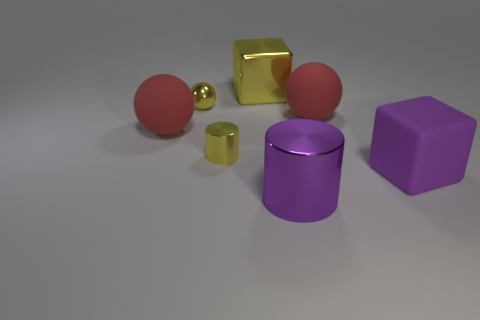The big object that is the same color as the small cylinder is what shape?
Make the answer very short. Cube. Does the small ball have the same color as the large metal block?
Offer a terse response. Yes. There is a shiny cylinder to the left of the purple cylinder; does it have the same size as the big cylinder?
Your response must be concise. No. How many other objects are the same shape as the purple matte thing?
Make the answer very short. 1. What number of brown objects are small spheres or small matte objects?
Ensure brevity in your answer.  0. There is a big cube that is to the right of the large purple metal object; does it have the same color as the big cylinder?
Ensure brevity in your answer.  Yes. The large thing that is the same material as the yellow cube is what shape?
Keep it short and to the point. Cylinder. There is a object that is right of the large shiny cylinder and behind the big purple matte object; what color is it?
Your answer should be compact. Red. There is a rubber ball that is in front of the red matte sphere to the right of the tiny cylinder; what is its size?
Offer a terse response. Large. Is there another tiny sphere of the same color as the shiny ball?
Your response must be concise. No. 